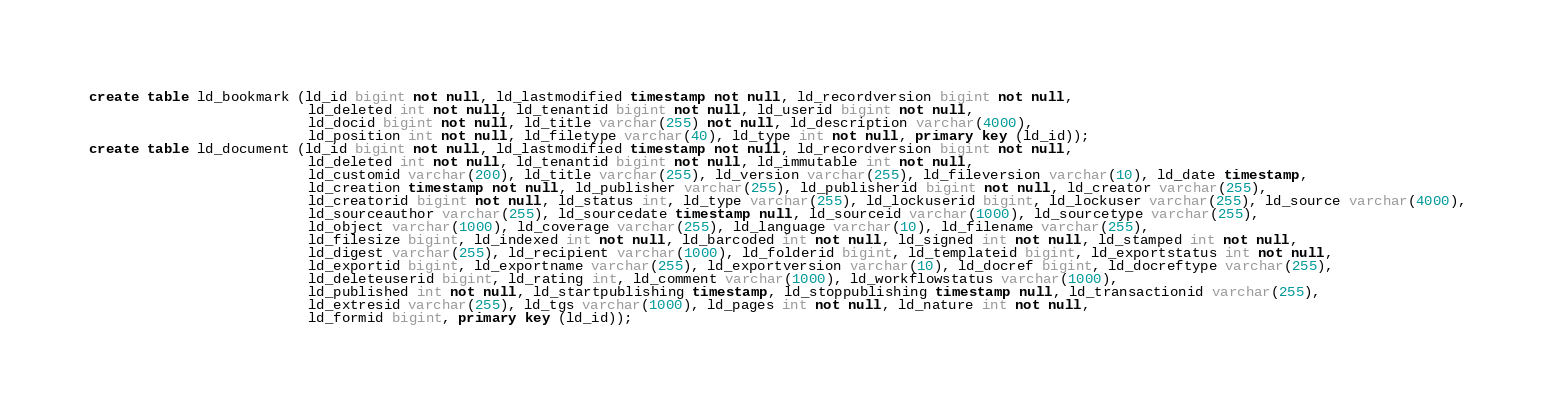<code> <loc_0><loc_0><loc_500><loc_500><_SQL_>create table ld_bookmark (ld_id bigint not null, ld_lastmodified timestamp not null, ld_recordversion bigint not null,
                          ld_deleted int not null, ld_tenantid bigint not null, ld_userid bigint not null, 
                          ld_docid bigint not null, ld_title varchar(255) not null, ld_description varchar(4000), 
                          ld_position int not null, ld_filetype varchar(40), ld_type int not null, primary key (ld_id));
create table ld_document (ld_id bigint not null, ld_lastmodified timestamp not null, ld_recordversion bigint not null, 
						  ld_deleted int not null, ld_tenantid bigint not null, ld_immutable int not null,
                          ld_customid varchar(200), ld_title varchar(255), ld_version varchar(255), ld_fileversion varchar(10), ld_date timestamp, 
                          ld_creation timestamp not null, ld_publisher varchar(255), ld_publisherid bigint not null, ld_creator varchar(255),
                          ld_creatorid bigint not null, ld_status int, ld_type varchar(255), ld_lockuserid bigint, ld_lockuser varchar(255), ld_source varchar(4000),
                          ld_sourceauthor varchar(255), ld_sourcedate timestamp null, ld_sourceid varchar(1000), ld_sourcetype varchar(255),
                          ld_object varchar(1000), ld_coverage varchar(255), ld_language varchar(10), ld_filename varchar(255), 
                          ld_filesize bigint, ld_indexed int not null, ld_barcoded int not null, ld_signed int not null, ld_stamped int not null, 
                          ld_digest varchar(255), ld_recipient varchar(1000), ld_folderid bigint, ld_templateid bigint, ld_exportstatus int not null, 
                          ld_exportid bigint, ld_exportname varchar(255), ld_exportversion varchar(10), ld_docref bigint, ld_docreftype varchar(255),
                          ld_deleteuserid bigint, ld_rating int, ld_comment varchar(1000), ld_workflowstatus varchar(1000), 
                          ld_published int not null, ld_startpublishing timestamp, ld_stoppublishing timestamp null, ld_transactionid varchar(255), 
                          ld_extresid varchar(255), ld_tgs varchar(1000), ld_pages int not null, ld_nature int not null,
                          ld_formid bigint, primary key (ld_id));</code> 